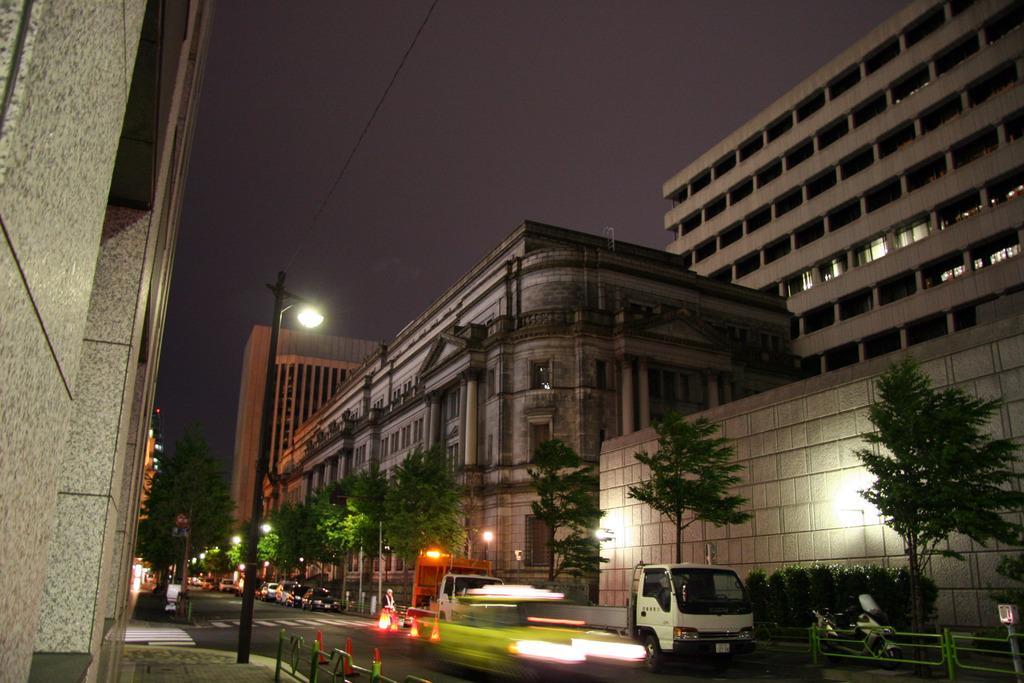Can you describe this image briefly? In this image, we can see vehicles and traffic cones on the road and in the background, there are trees, poles, buildings and lights. 